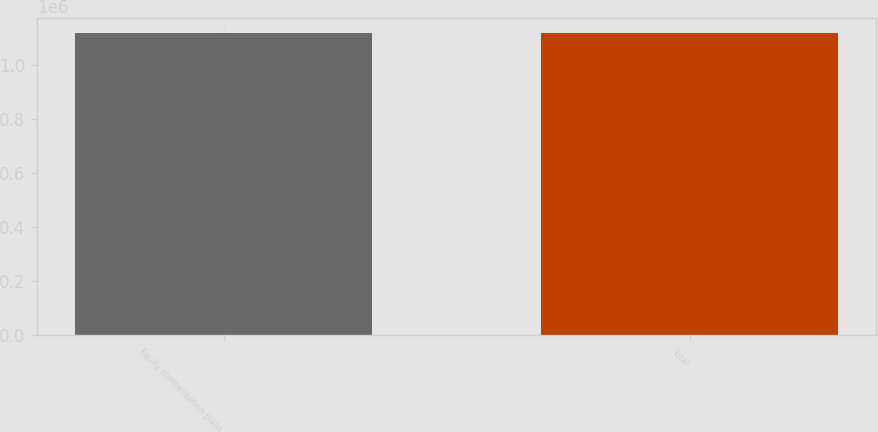<chart> <loc_0><loc_0><loc_500><loc_500><bar_chart><fcel>Equity compensation plans<fcel>Total<nl><fcel>1.11743e+06<fcel>1.11743e+06<nl></chart> 